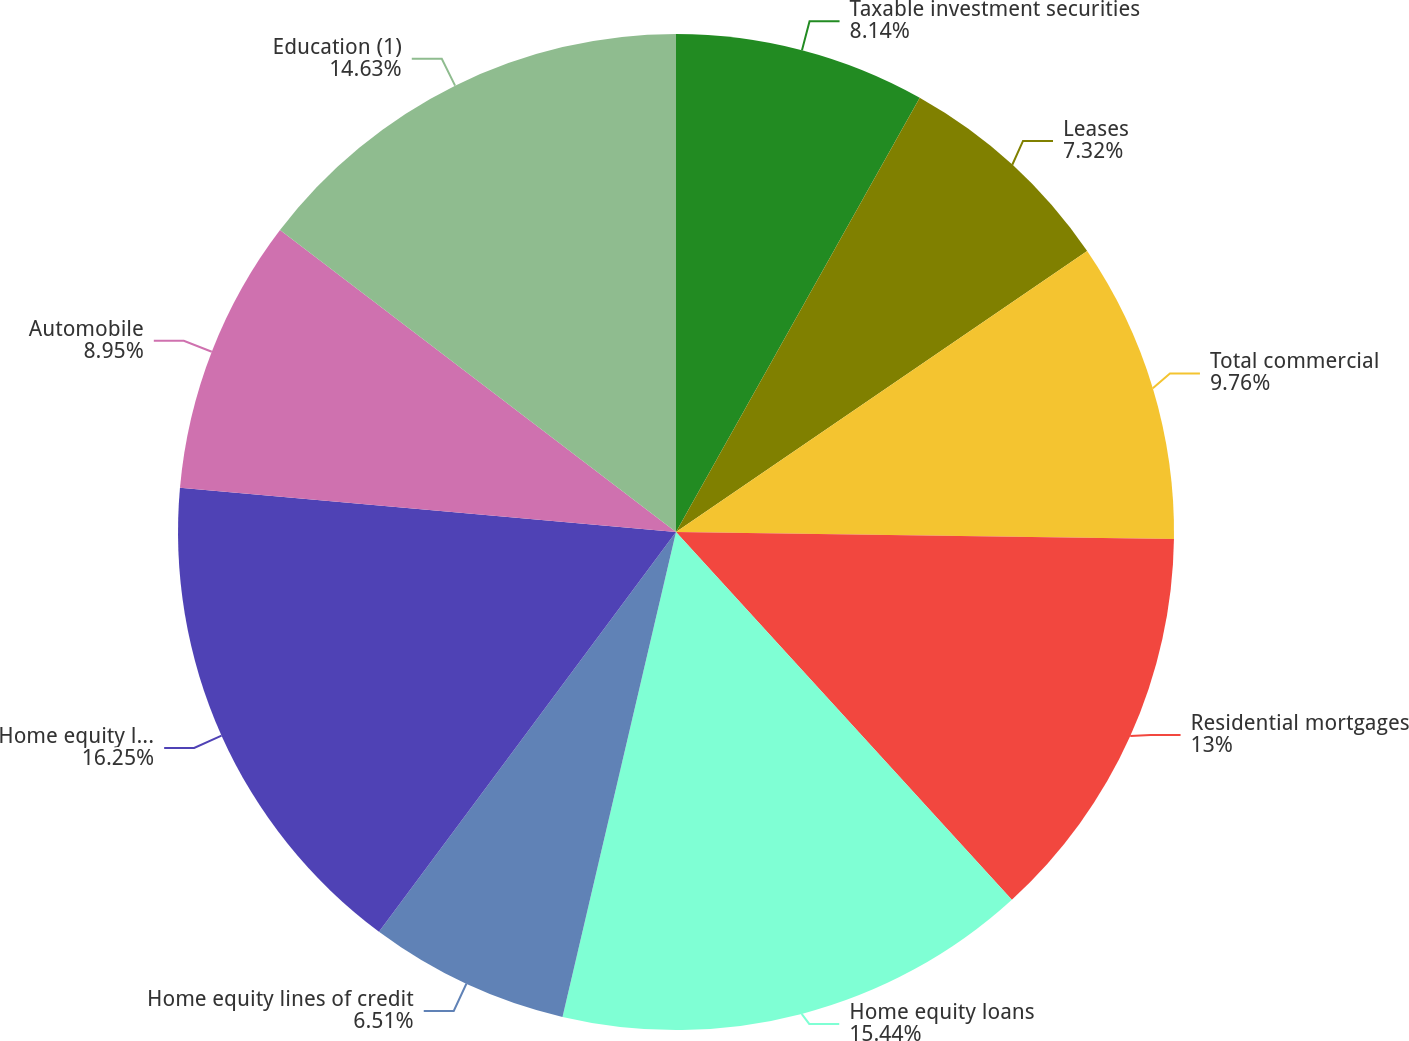Convert chart. <chart><loc_0><loc_0><loc_500><loc_500><pie_chart><fcel>Taxable investment securities<fcel>Leases<fcel>Total commercial<fcel>Residential mortgages<fcel>Home equity loans<fcel>Home equity lines of credit<fcel>Home equity loans serviced by<fcel>Automobile<fcel>Education (1)<nl><fcel>8.14%<fcel>7.32%<fcel>9.76%<fcel>13.0%<fcel>15.44%<fcel>6.51%<fcel>16.25%<fcel>8.95%<fcel>14.63%<nl></chart> 